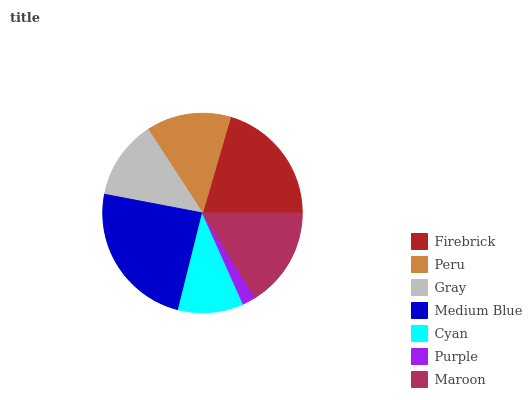Is Purple the minimum?
Answer yes or no. Yes. Is Medium Blue the maximum?
Answer yes or no. Yes. Is Peru the minimum?
Answer yes or no. No. Is Peru the maximum?
Answer yes or no. No. Is Firebrick greater than Peru?
Answer yes or no. Yes. Is Peru less than Firebrick?
Answer yes or no. Yes. Is Peru greater than Firebrick?
Answer yes or no. No. Is Firebrick less than Peru?
Answer yes or no. No. Is Peru the high median?
Answer yes or no. Yes. Is Peru the low median?
Answer yes or no. Yes. Is Cyan the high median?
Answer yes or no. No. Is Purple the low median?
Answer yes or no. No. 